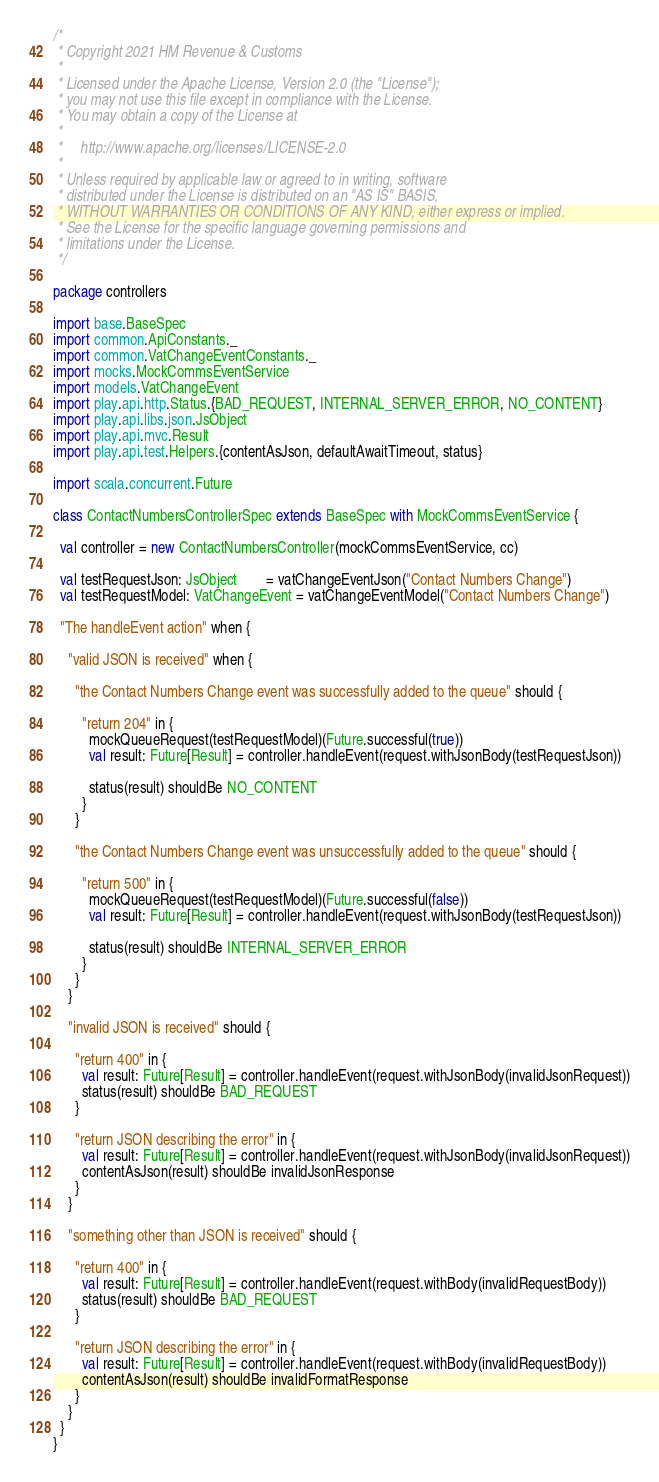<code> <loc_0><loc_0><loc_500><loc_500><_Scala_>/*
 * Copyright 2021 HM Revenue & Customs
 *
 * Licensed under the Apache License, Version 2.0 (the "License");
 * you may not use this file except in compliance with the License.
 * You may obtain a copy of the License at
 *
 *     http://www.apache.org/licenses/LICENSE-2.0
 *
 * Unless required by applicable law or agreed to in writing, software
 * distributed under the License is distributed on an "AS IS" BASIS,
 * WITHOUT WARRANTIES OR CONDITIONS OF ANY KIND, either express or implied.
 * See the License for the specific language governing permissions and
 * limitations under the License.
 */

package controllers

import base.BaseSpec
import common.ApiConstants._
import common.VatChangeEventConstants._
import mocks.MockCommsEventService
import models.VatChangeEvent
import play.api.http.Status.{BAD_REQUEST, INTERNAL_SERVER_ERROR, NO_CONTENT}
import play.api.libs.json.JsObject
import play.api.mvc.Result
import play.api.test.Helpers.{contentAsJson, defaultAwaitTimeout, status}

import scala.concurrent.Future

class ContactNumbersControllerSpec extends BaseSpec with MockCommsEventService {

  val controller = new ContactNumbersController(mockCommsEventService, cc)

  val testRequestJson: JsObject        = vatChangeEventJson("Contact Numbers Change")
  val testRequestModel: VatChangeEvent = vatChangeEventModel("Contact Numbers Change")

  "The handleEvent action" when {

    "valid JSON is received" when {

      "the Contact Numbers Change event was successfully added to the queue" should {

        "return 204" in {
          mockQueueRequest(testRequestModel)(Future.successful(true))
          val result: Future[Result] = controller.handleEvent(request.withJsonBody(testRequestJson))

          status(result) shouldBe NO_CONTENT
        }
      }

      "the Contact Numbers Change event was unsuccessfully added to the queue" should {

        "return 500" in {
          mockQueueRequest(testRequestModel)(Future.successful(false))
          val result: Future[Result] = controller.handleEvent(request.withJsonBody(testRequestJson))

          status(result) shouldBe INTERNAL_SERVER_ERROR
        }
      }
    }

    "invalid JSON is received" should {

      "return 400" in {
        val result: Future[Result] = controller.handleEvent(request.withJsonBody(invalidJsonRequest))
        status(result) shouldBe BAD_REQUEST
      }

      "return JSON describing the error" in {
        val result: Future[Result] = controller.handleEvent(request.withJsonBody(invalidJsonRequest))
        contentAsJson(result) shouldBe invalidJsonResponse
      }
    }

    "something other than JSON is received" should {

      "return 400" in {
        val result: Future[Result] = controller.handleEvent(request.withBody(invalidRequestBody))
        status(result) shouldBe BAD_REQUEST
      }

      "return JSON describing the error" in {
        val result: Future[Result] = controller.handleEvent(request.withBody(invalidRequestBody))
        contentAsJson(result) shouldBe invalidFormatResponse
      }
    }
  }
}
</code> 